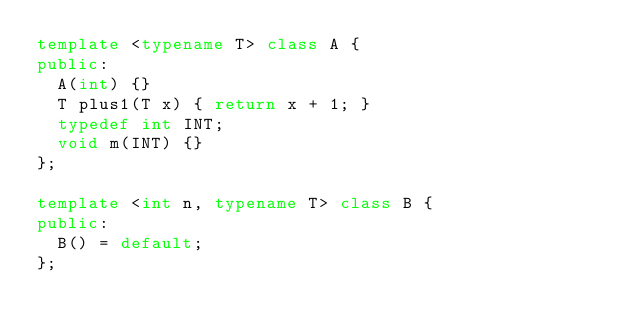<code> <loc_0><loc_0><loc_500><loc_500><_C++_>template <typename T> class A {
public:
  A(int) {}
  T plus1(T x) { return x + 1; }
  typedef int INT;
  void m(INT) {}
};

template <int n, typename T> class B {
public:
  B() = default;
};
</code> 